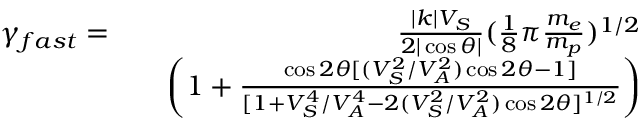Convert formula to latex. <formula><loc_0><loc_0><loc_500><loc_500>\begin{array} { r l r } { \gamma _ { f a s t } = } & { \frac { | k | V _ { S } } { 2 | \cos \theta | } ( \frac { 1 } { 8 } \pi \frac { m _ { e } } { m _ { p } } ) ^ { 1 / 2 } } \\ & { \left ( 1 + \frac { \cos 2 \theta [ ( V _ { S } ^ { 2 } / V _ { A } ^ { 2 } ) \cos 2 \theta - 1 ] } { [ 1 + V _ { S } ^ { 4 } / V _ { A } ^ { 4 } - 2 ( V _ { S } ^ { 2 } / V _ { A } ^ { 2 } ) \cos 2 \theta ] ^ { 1 / 2 } } \right ) } \end{array}</formula> 